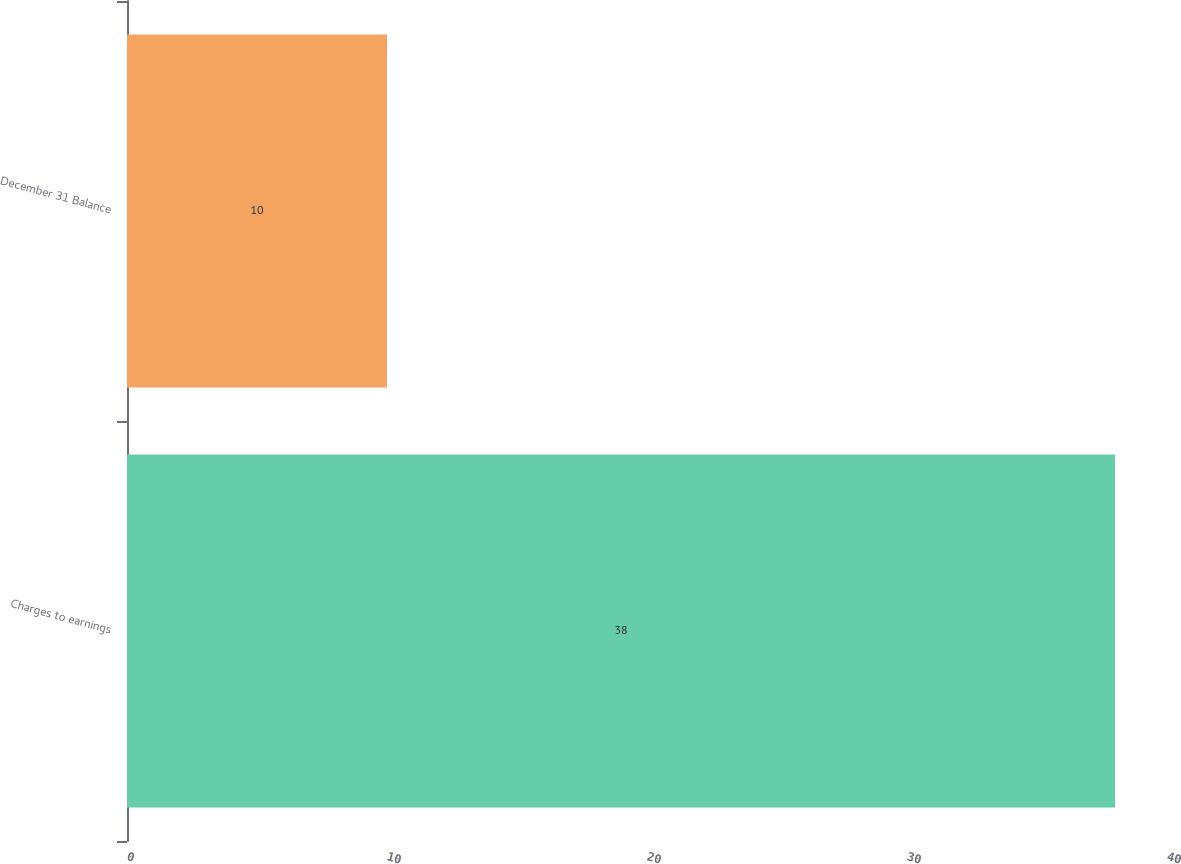<chart> <loc_0><loc_0><loc_500><loc_500><bar_chart><fcel>Charges to earnings<fcel>December 31 Balance<nl><fcel>38<fcel>10<nl></chart> 